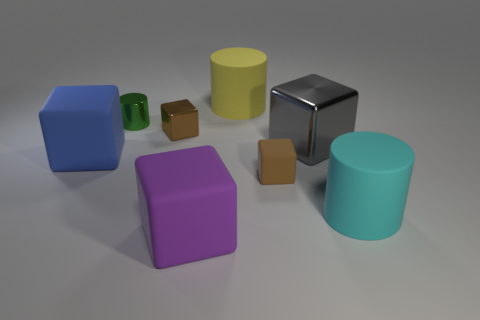What color is the big matte thing that is behind the large gray thing?
Your answer should be compact. Yellow. How many purple rubber things are there?
Your answer should be very brief. 1. The brown object that is the same material as the big yellow object is what shape?
Your response must be concise. Cube. There is a tiny block to the left of the big yellow rubber cylinder; does it have the same color as the cylinder that is in front of the blue rubber block?
Offer a terse response. No. Are there the same number of big objects to the left of the big metallic block and big matte cylinders?
Your answer should be very brief. No. How many gray things are on the left side of the small cylinder?
Your answer should be very brief. 0. What size is the yellow object?
Keep it short and to the point. Large. What is the color of the other tiny thing that is made of the same material as the blue thing?
Keep it short and to the point. Brown. How many purple matte cubes have the same size as the blue block?
Your response must be concise. 1. Is the small brown cube behind the large blue cube made of the same material as the small cylinder?
Offer a very short reply. Yes. 